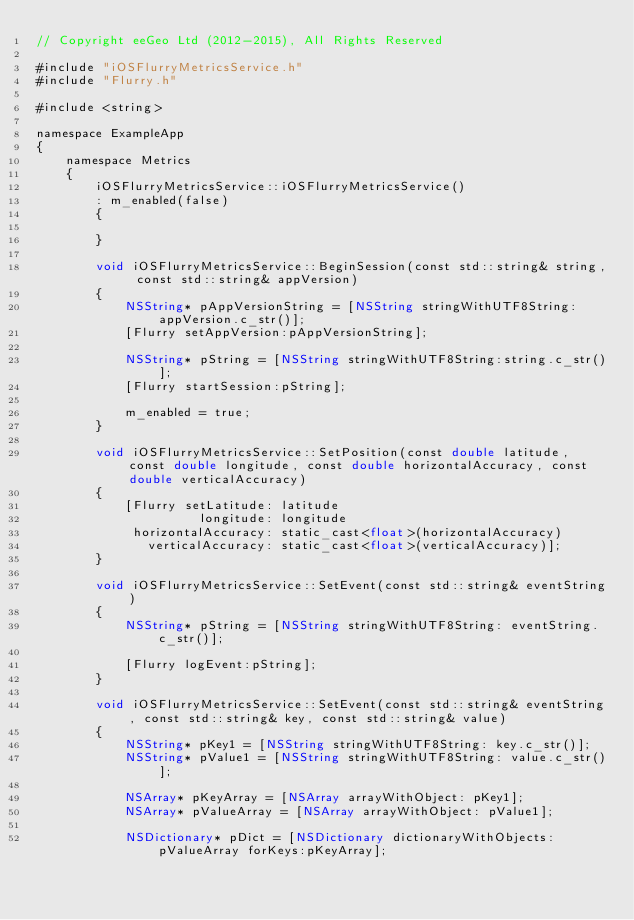<code> <loc_0><loc_0><loc_500><loc_500><_ObjectiveC_>// Copyright eeGeo Ltd (2012-2015), All Rights Reserved

#include "iOSFlurryMetricsService.h"
#include "Flurry.h"

#include <string>

namespace ExampleApp
{
    namespace Metrics
    {
        iOSFlurryMetricsService::iOSFlurryMetricsService()
        : m_enabled(false)
        {
            
        }
        
        void iOSFlurryMetricsService::BeginSession(const std::string& string, const std::string& appVersion)
        {
            NSString* pAppVersionString = [NSString stringWithUTF8String:appVersion.c_str()];
            [Flurry setAppVersion:pAppVersionString];
            
            NSString* pString = [NSString stringWithUTF8String:string.c_str()];
            [Flurry startSession:pString];
            
            m_enabled = true;
        }
        
        void iOSFlurryMetricsService::SetPosition(const double latitude, const double longitude, const double horizontalAccuracy, const double verticalAccuracy)
        {
            [Flurry setLatitude: latitude
                      longitude: longitude
             horizontalAccuracy: static_cast<float>(horizontalAccuracy)
               verticalAccuracy: static_cast<float>(verticalAccuracy)];
        }
        
        void iOSFlurryMetricsService::SetEvent(const std::string& eventString)
        {
            NSString* pString = [NSString stringWithUTF8String: eventString.c_str()];
            
            [Flurry logEvent:pString];
        }
        
        void iOSFlurryMetricsService::SetEvent(const std::string& eventString, const std::string& key, const std::string& value)
        {
            NSString* pKey1 = [NSString stringWithUTF8String: key.c_str()];
            NSString* pValue1 = [NSString stringWithUTF8String: value.c_str()];
            
            NSArray* pKeyArray = [NSArray arrayWithObject: pKey1];
            NSArray* pValueArray = [NSArray arrayWithObject: pValue1];
            
            NSDictionary* pDict = [NSDictionary dictionaryWithObjects:pValueArray forKeys:pKeyArray];</code> 